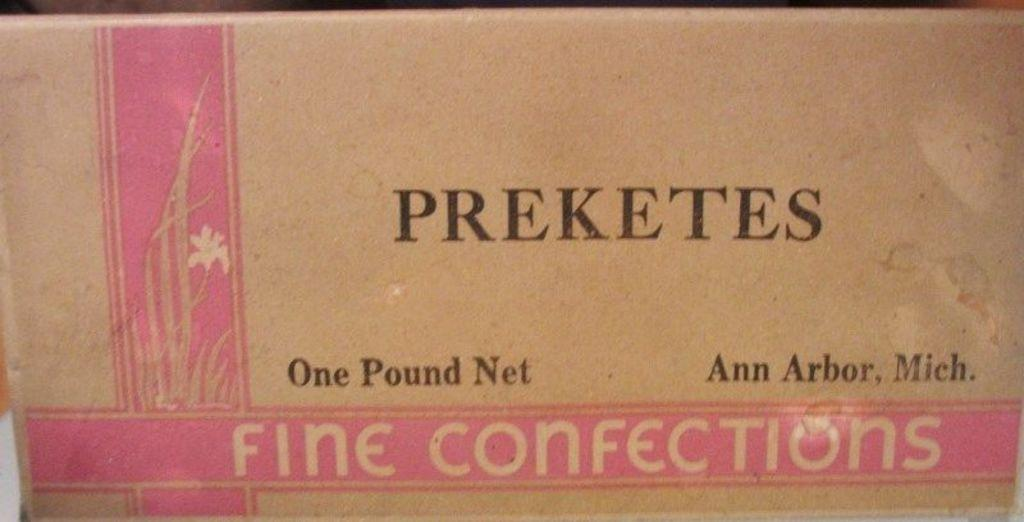<image>
Share a concise interpretation of the image provided. a close up of Fine Confections from Preketes 